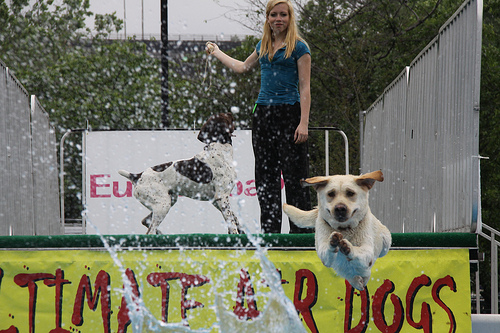<image>
Is the dog under the water? No. The dog is not positioned under the water. The vertical relationship between these objects is different. 